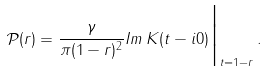<formula> <loc_0><loc_0><loc_500><loc_500>\mathcal { P } ( r ) = \frac { \gamma } { \pi ( 1 - r ) ^ { 2 } } I m \, K ( t - i 0 ) \Big | _ { t = 1 - r } \, .</formula> 